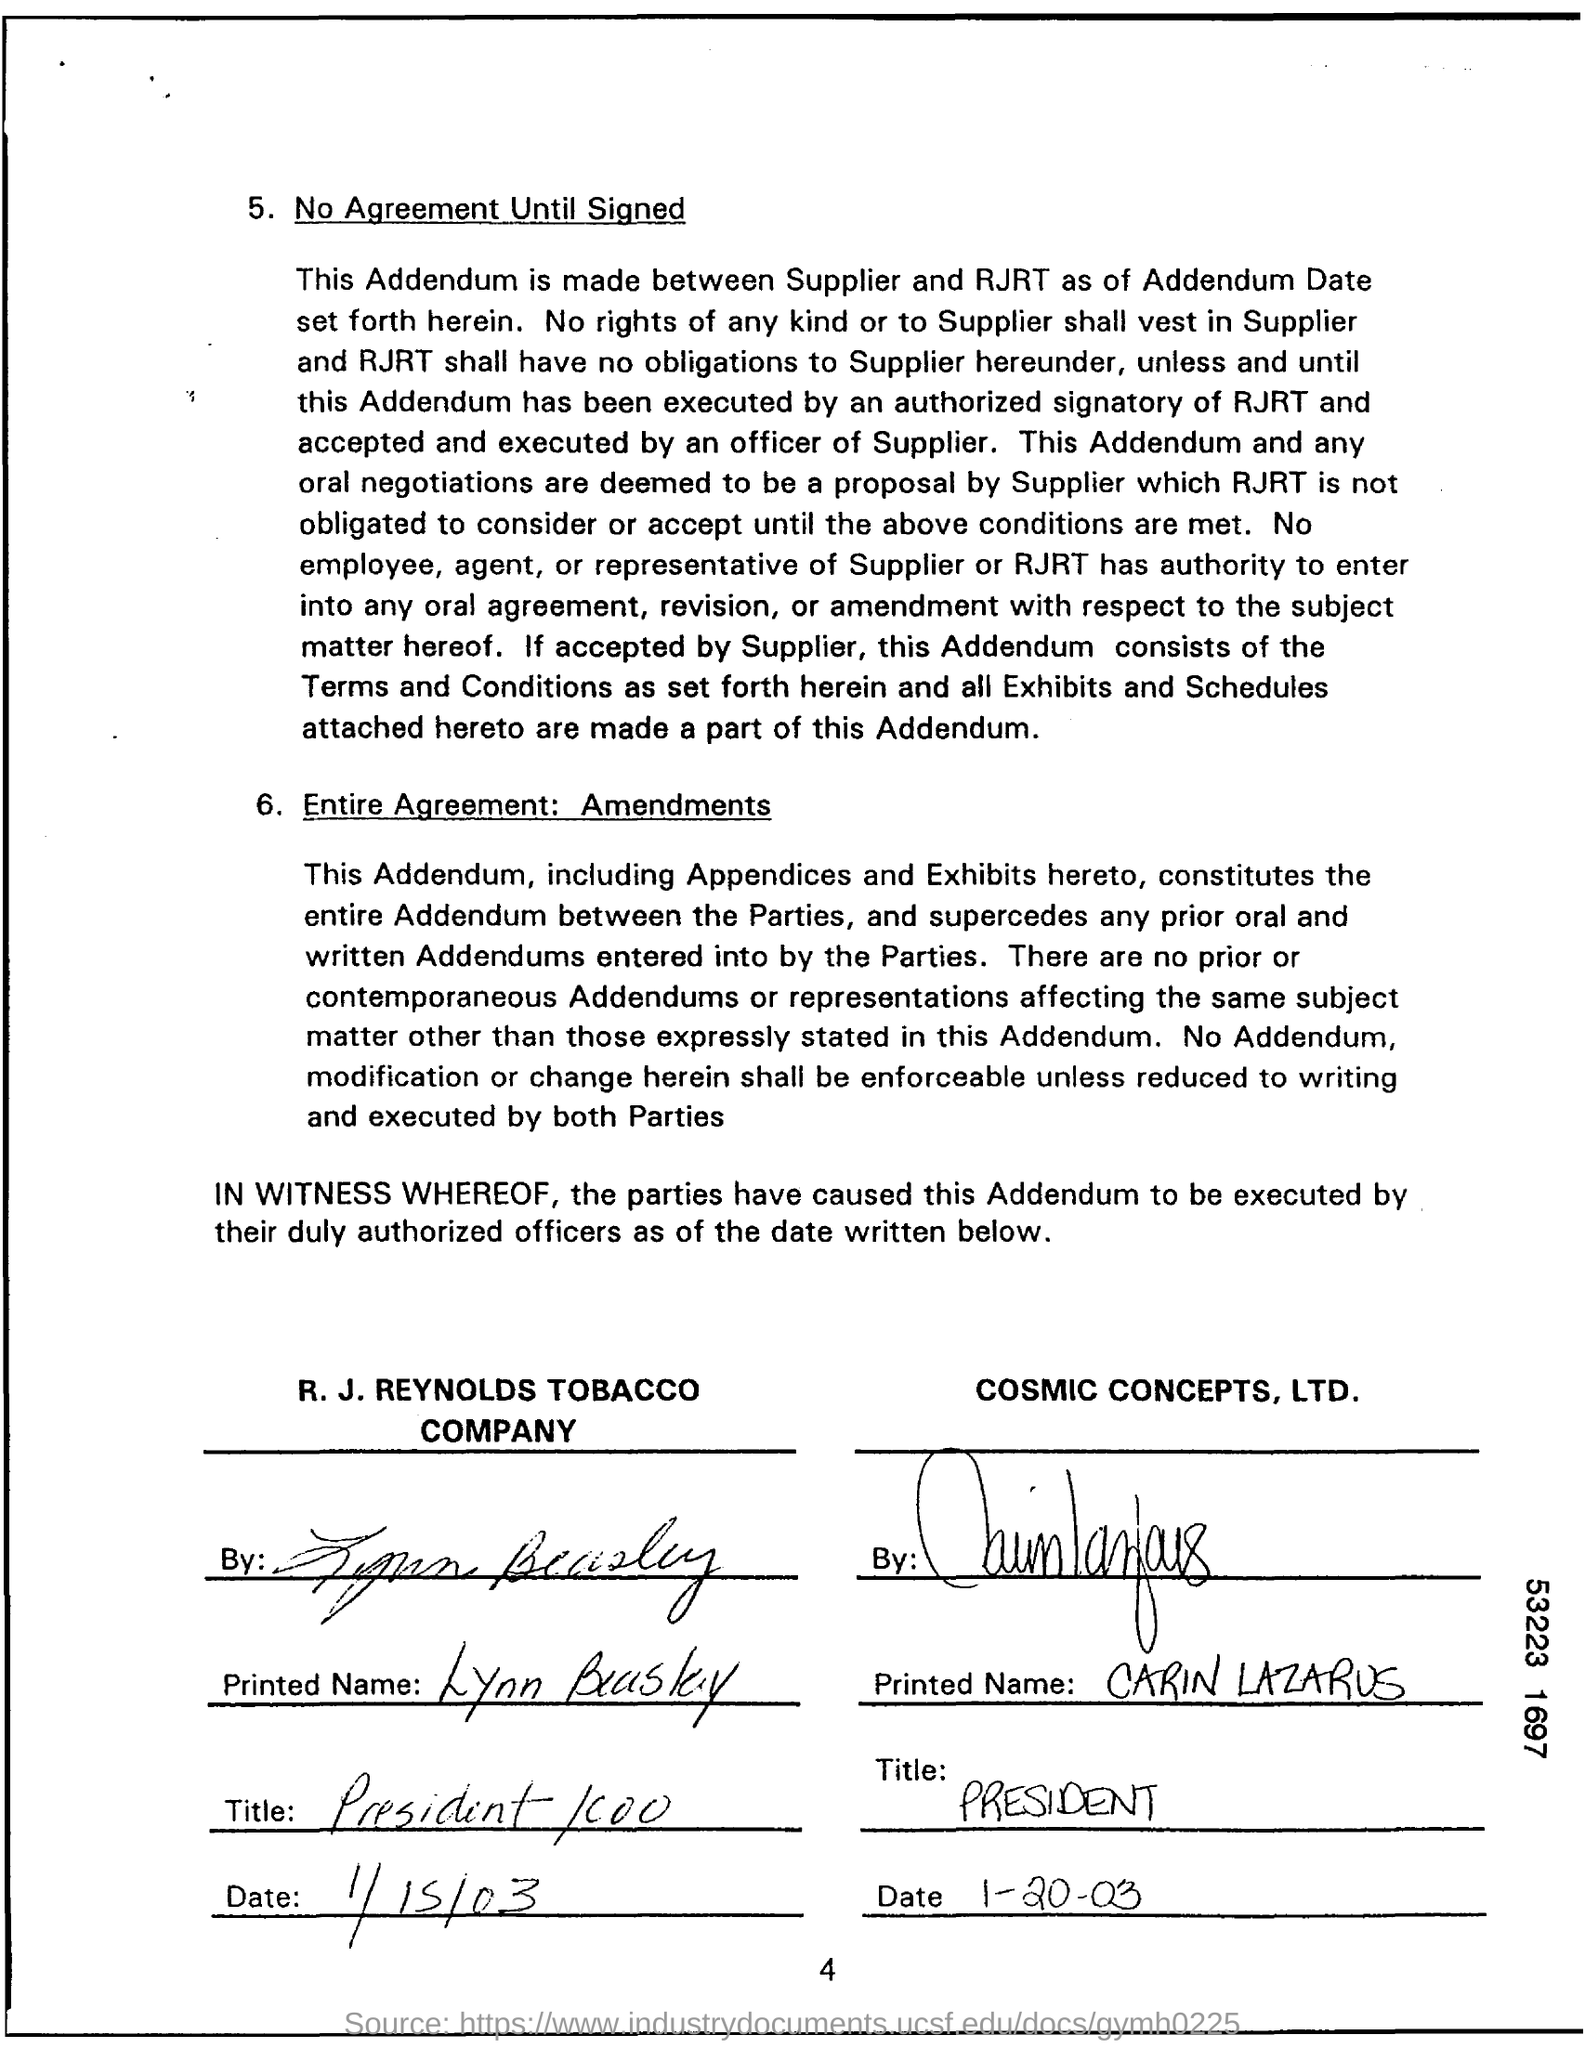Point out several critical features in this image. The title of CARIN LAZARUS is President. The Addendum was made between the supplier and RJRT. The supplier is Cosmic Concepts, LTD. The president and COO of R.J. Reynolds Tobacco Company is Lynn Beasley. 